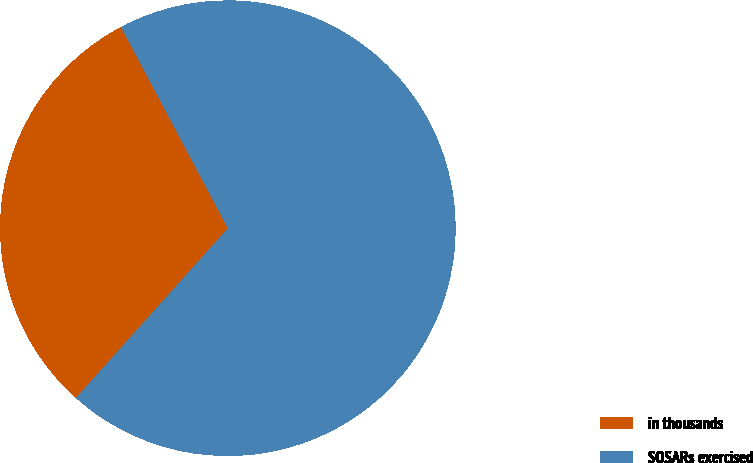Convert chart. <chart><loc_0><loc_0><loc_500><loc_500><pie_chart><fcel>in thousands<fcel>SOSARs exercised<nl><fcel>30.61%<fcel>69.39%<nl></chart> 